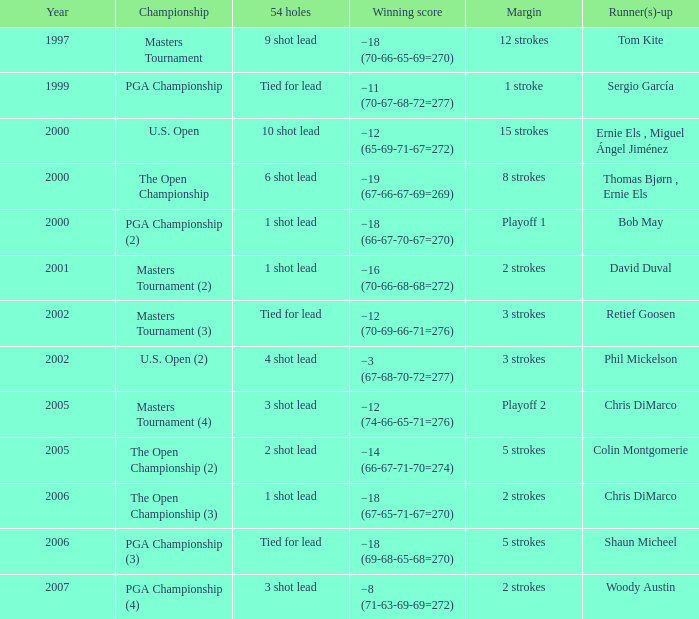In which 54-hole event does the winner have a score of -19 (67-66-67-69=269)? 6 shot lead. 